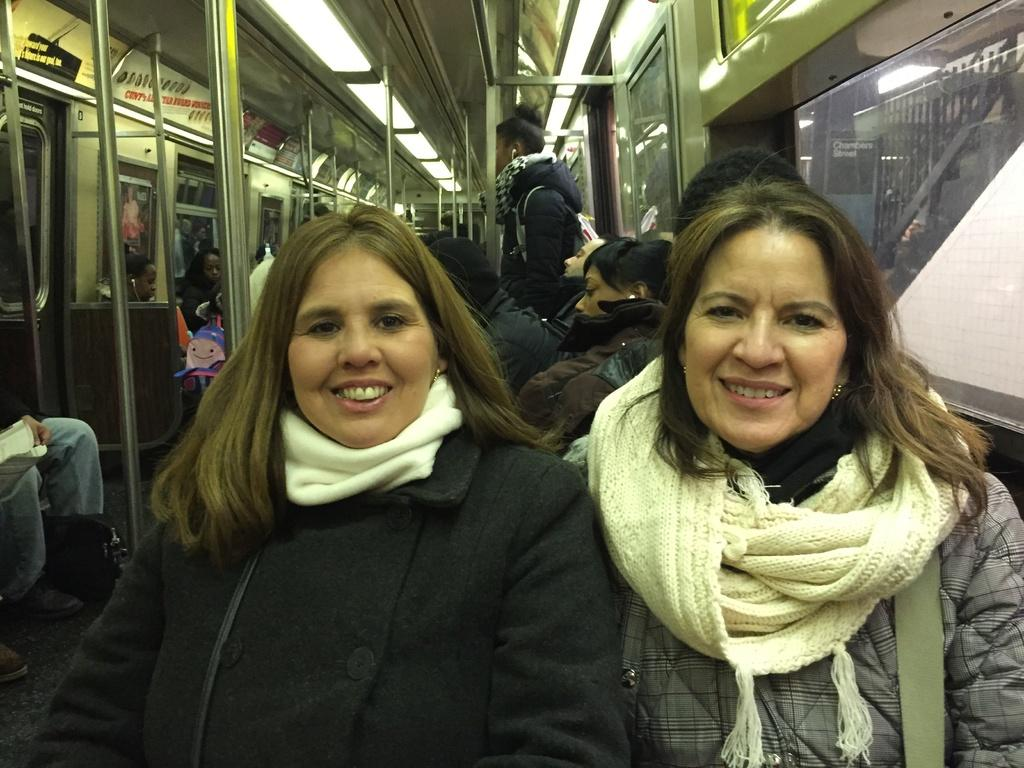How many ladies are sitting in the train in the image? There are two ladies sitting in the train in the image. What is the lady at the top of the image doing? The lady at the top of the image is wearing earphones and standing. What expert advice is the lady at the top of the image providing in the image? There is no expert advice being provided in the image, as the lady at the top of the image is simply standing and wearing earphones. What story is the lady sitting on the right side of the train telling in the image? There is no story being told in the image, as the ladies are sitting in the train and no conversation is depicted. 